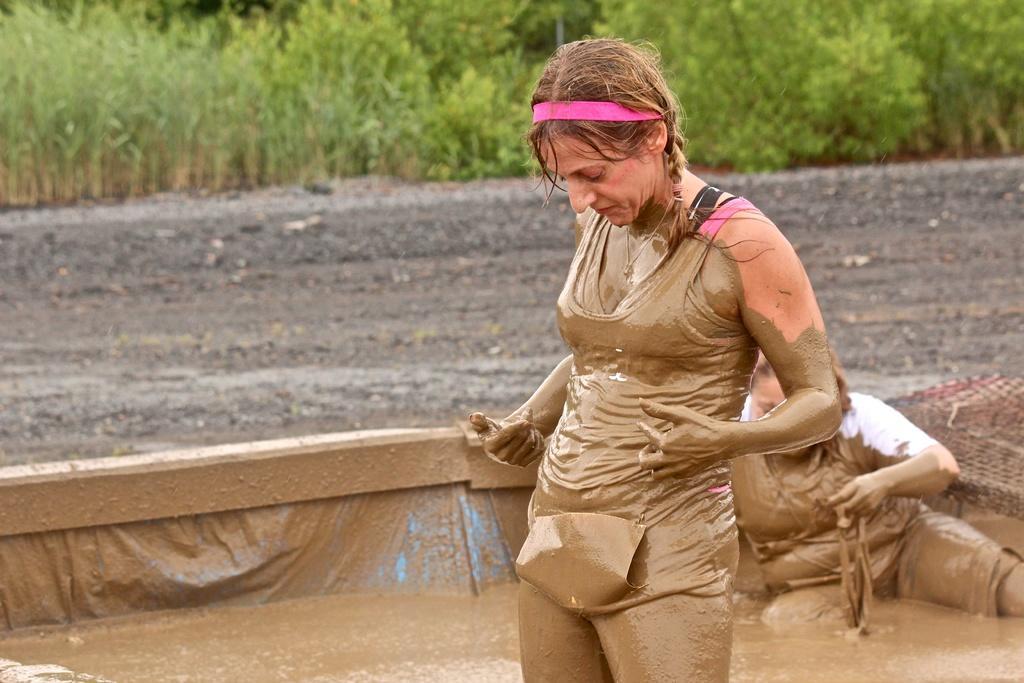How would you summarize this image in a sentence or two? This picture is clicked outside. On the right there is a woman standing on the ground. In the foreground we can see the mud and a person sitting on the ground. In the background we can see the trees and the gravels. 